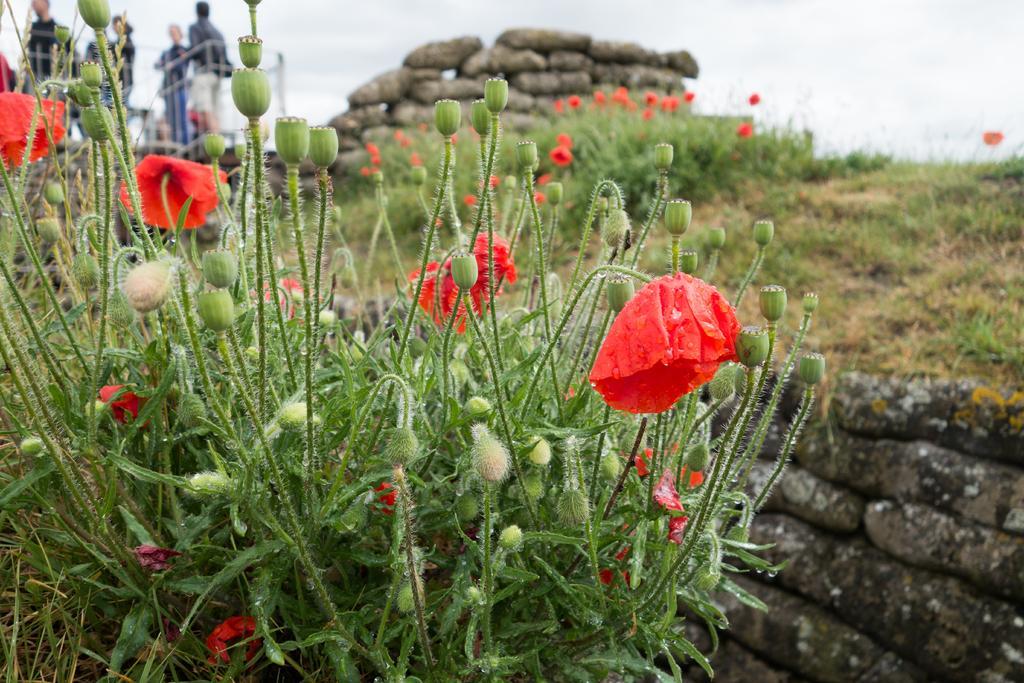In one or two sentences, can you explain what this image depicts? In this image we can see some plants with flowers and buds on it, there are some stones, people and grass on the ground, in the background, we can see the sky. 